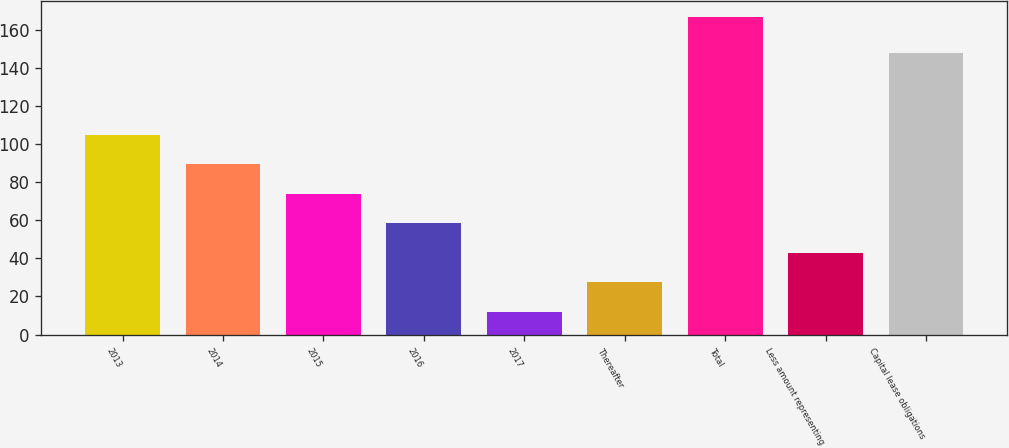Convert chart. <chart><loc_0><loc_0><loc_500><loc_500><bar_chart><fcel>2013<fcel>2014<fcel>2015<fcel>2016<fcel>2017<fcel>Thereafter<fcel>Total<fcel>Less amount representing<fcel>Capital lease obligations<nl><fcel>105<fcel>89.5<fcel>74<fcel>58.5<fcel>12<fcel>27.5<fcel>167<fcel>43<fcel>148<nl></chart> 